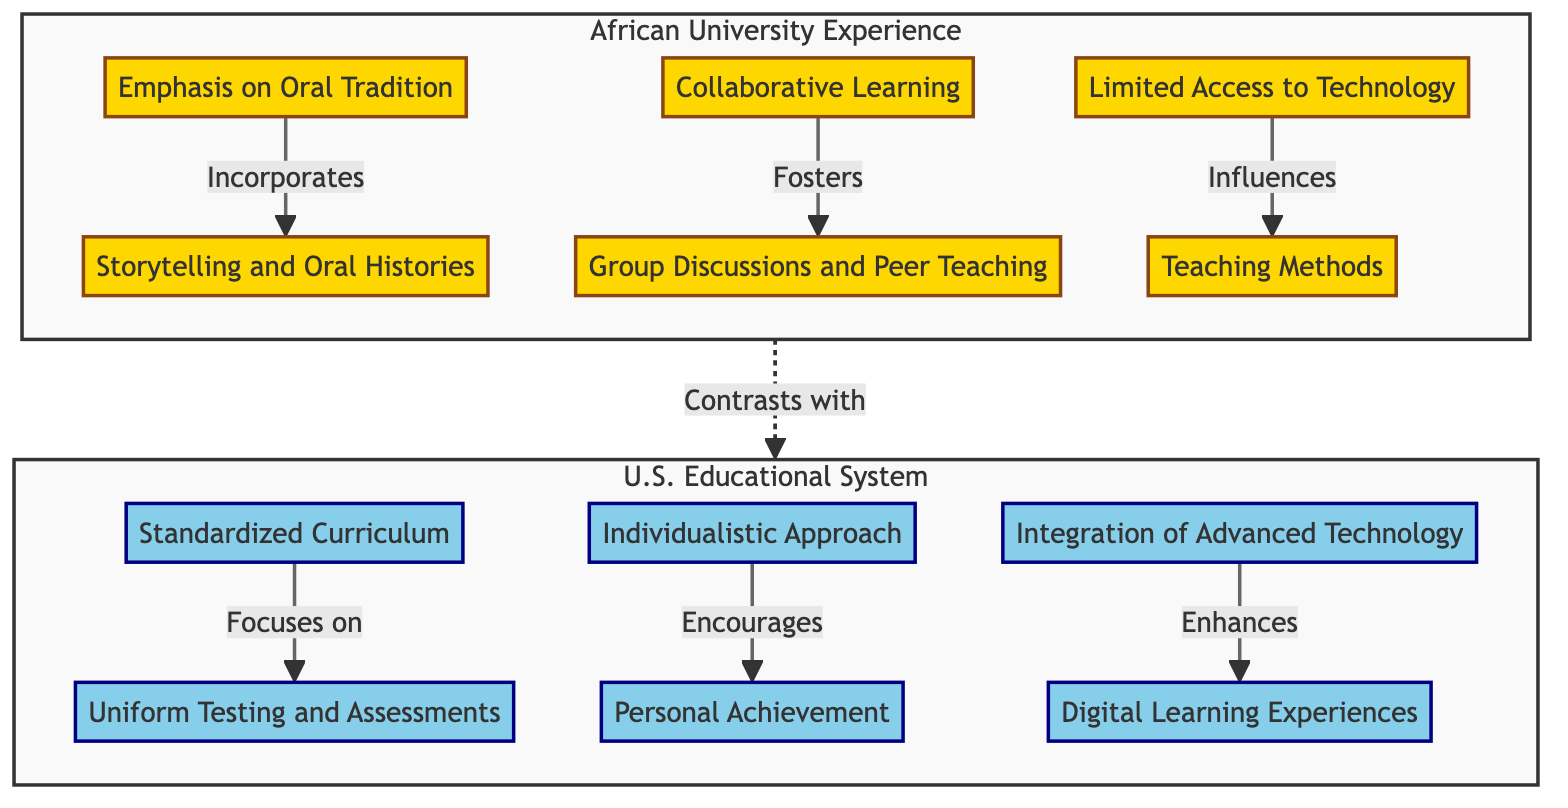What is a key feature of African teaching methodology? The diagram identifies "Emphasis on Oral Tradition" as a key characteristic, indicating that storytelling and oral histories are significant aspects of teaching.
Answer: Emphasis on Oral Tradition How many elements are present in the African University subgraph? By examining the African University subgraph, we see five distinct elements: Emphasis on Oral Tradition, Collaborative Learning, Limited Access to Technology, and their respective connections.
Answer: 3 What does "Collaborative Learning" foster? The diagram specifies that "Collaborative Learning" fosters group discussions and peer teaching, illustrating its focus on communal engagement.
Answer: Group Discussions and Peer Teaching How does the U.S. educational environment approach personal achievement? The diagram states that the U.S. Educational Environment encourages an individualistic approach, highlighting personal motivation as a necessary aspect of learning.
Answer: Individualistic Approach What influences teaching methods in African universities? "Limited Access to Technology" is shown to influence teaching methods, indicating resource availability directly affects educational practices.
Answer: Limited Access to Technology What is the relationship between "Standardized Curriculum" and assessments in the U.S.? The diagram illustrates that "Standardized Curriculum" focuses on uniform testing and assessments, establishing a clear connection between curriculum and evaluation methods.
Answer: Focuses on Uniform Testing and Assessments What contrasts with the U.S. educational system? The diagram indicates that the teaching methodologies observed in African universities contrast with those in the U.S. Educational System, highlighting differences in approaches.
Answer: Teaching methodologies What does integration of advanced technology enhance in the U.S. system? The diagram specifies that the integration of advanced technology enhances digital learning experiences, denoting an improvement in the quality of education through technology.
Answer: Digital Learning Experiences What type of learning environment does African universities promote? The diagram shows that "Collaborative Learning" promotes a communal learning environment, emphasizing group engagement among students.
Answer: Communal Learning Environment What aspect is emphasized in the African University subgraph? The diagram emphasizes the importance of community knowledge in the learning process, as demonstrated by the focus on oral traditions and collaborative learning.
Answer: Community Knowledge 